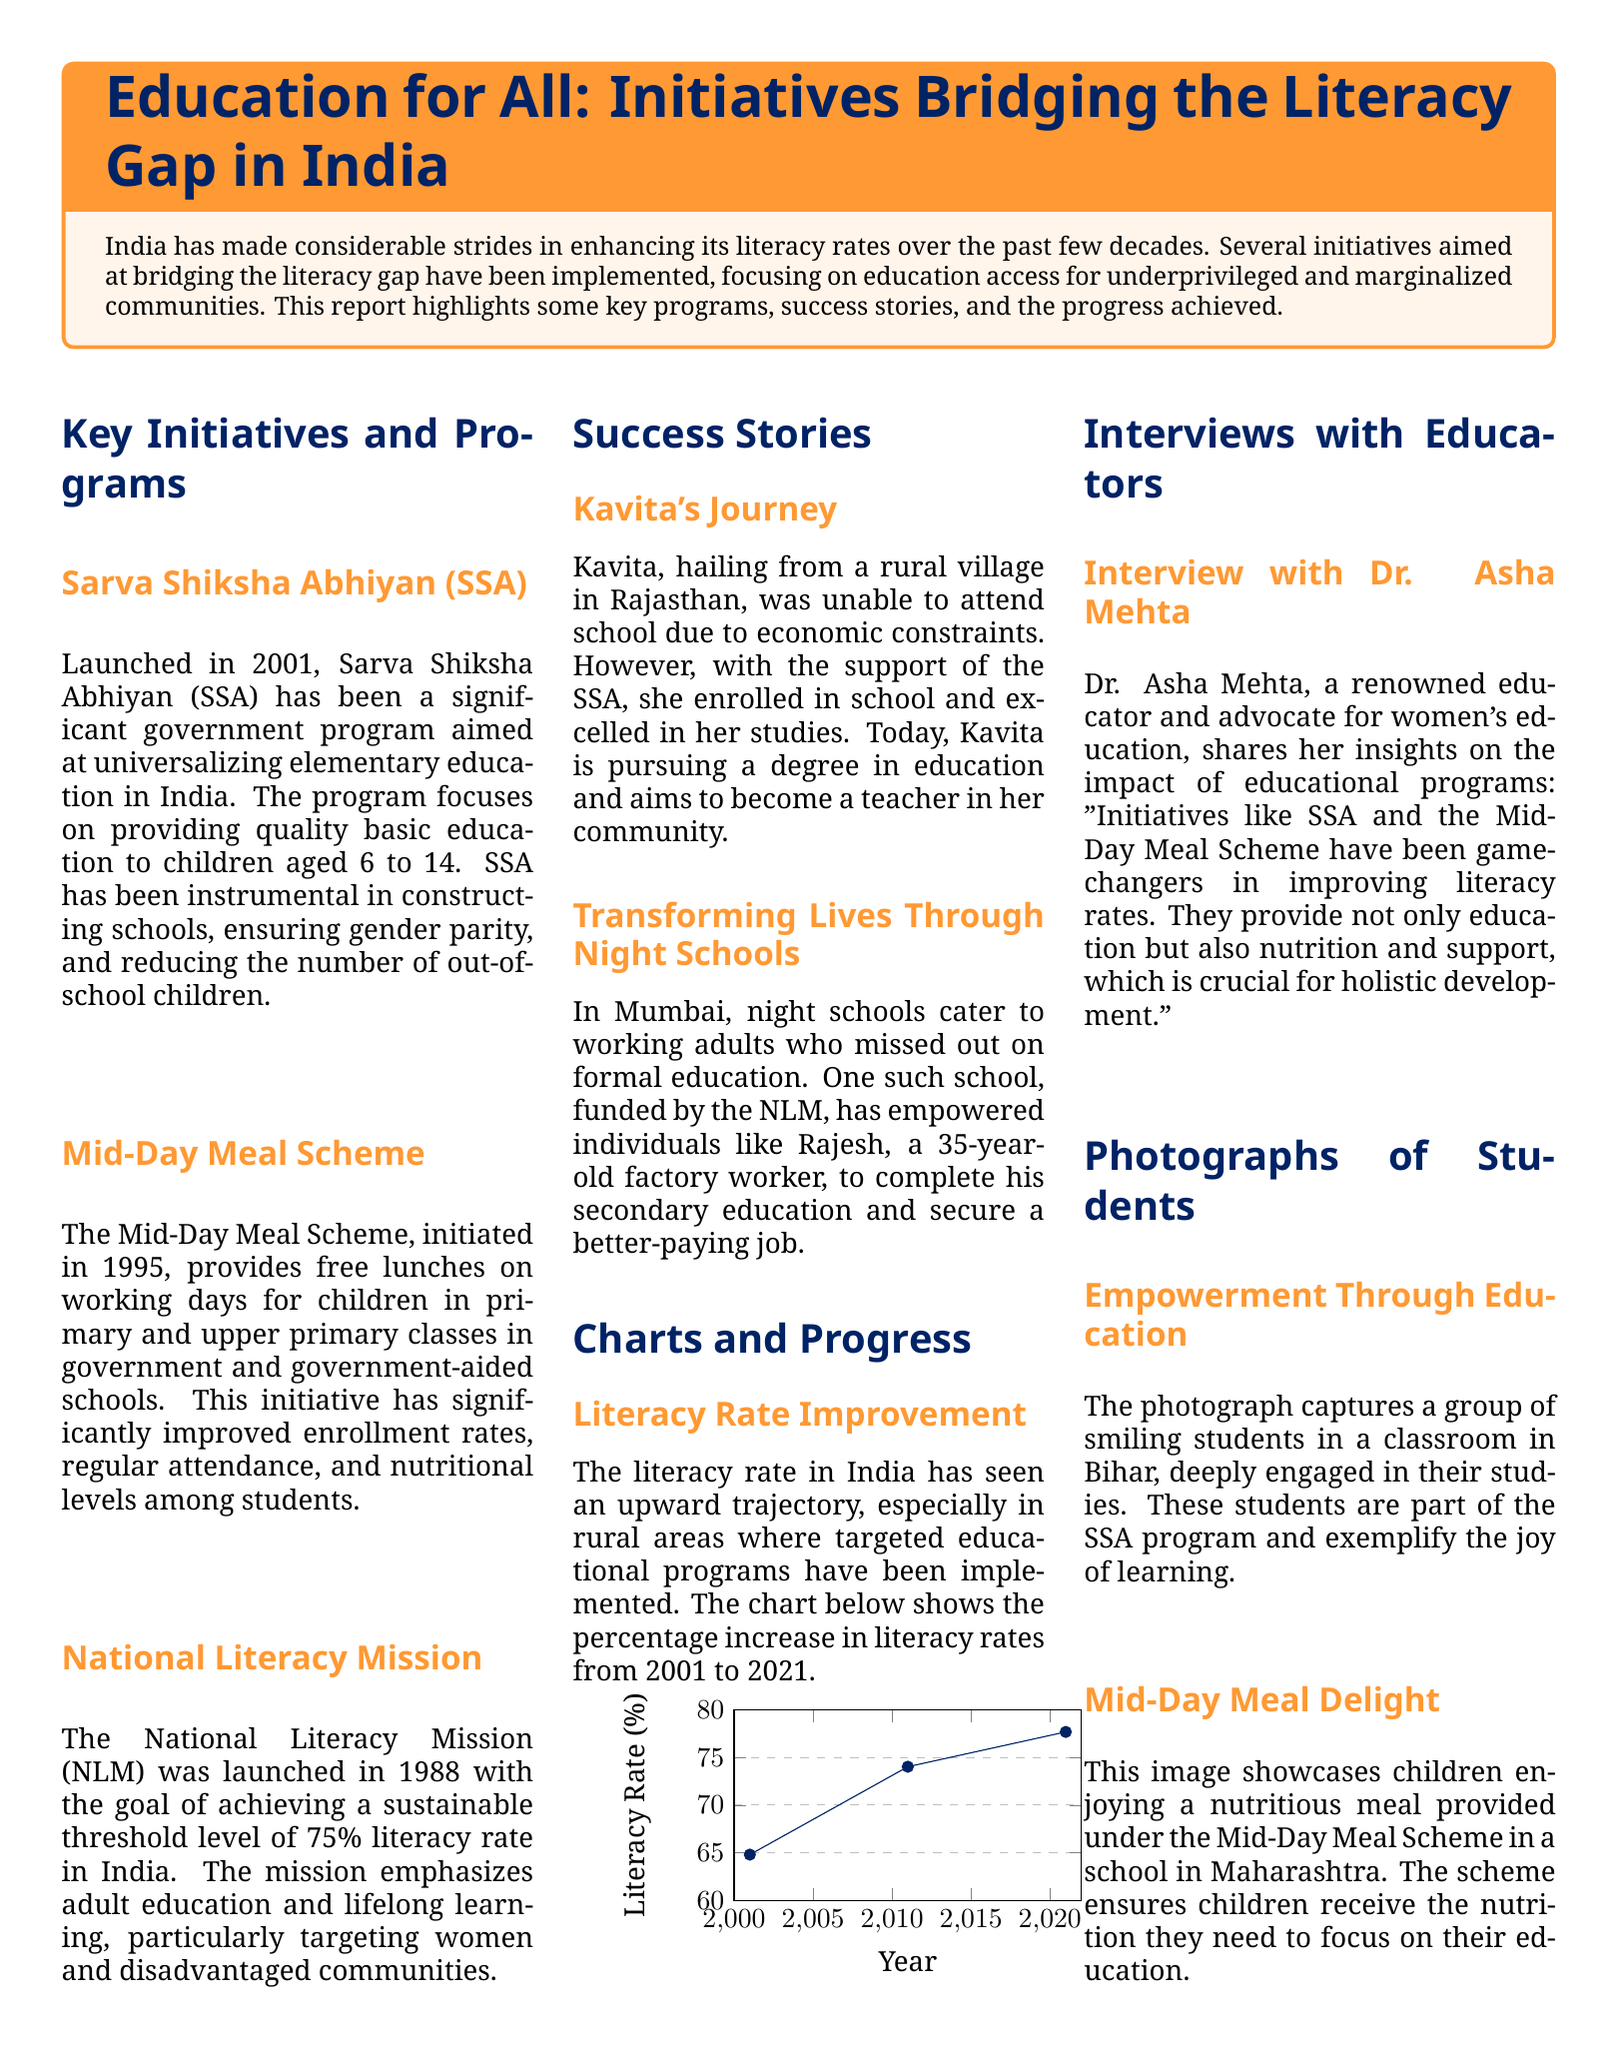what initiative was launched in 2001? The document states that the Sarva Shiksha Abhiyan (SSA) was launched in 2001 aimed at universalizing elementary education.
Answer: Sarva Shiksha Abhiyan (SSA) what age group does SSA focus on? The SSA program focuses on providing education to children aged 6 to 14.
Answer: 6 to 14 what percentage increase in literacy was observed from 2011 to 2021? The literacy rate increased from 74.04% in 2011 to 77.7% in 2021, which is a difference of 3.66%.
Answer: 3.66% who is Kavita? Kavita is a student from a rural village in Rajasthan who excelled in her studies after enrolling in school through the support of the SSA.
Answer: A student from Rajasthan what does the Mid-Day Meal Scheme provide? The Mid-Day Meal Scheme provides free lunches on working days for children in primary and upper primary classes.
Answer: Free lunches what has been a game-changer in improving literacy rates according to Dr. Asha Mehta? Dr. Asha Mehta mentions that initiatives like SSA and the Mid-Day Meal Scheme have been game-changers in improving literacy rates.
Answer: SSA and the Mid-Day Meal Scheme what is the primary target of the National Literacy Mission? The primary target of the National Literacy Mission is adult education, focusing on women and disadvantaged communities.
Answer: Adult education which region saw notable literacy rate improvements according to the document? The document indicates that rural areas saw notable improvements in literacy rates due to targeted educational programs.
Answer: Rural areas 